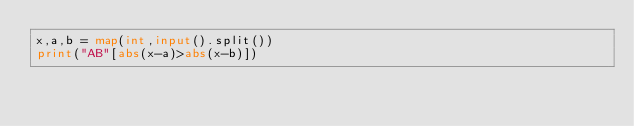<code> <loc_0><loc_0><loc_500><loc_500><_Python_>x,a,b = map(int,input().split())
print("AB"[abs(x-a)>abs(x-b)])</code> 